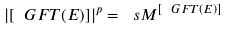Convert formula to latex. <formula><loc_0><loc_0><loc_500><loc_500>\left | [ \ G F T ( E ) ] \right | ^ { p } = \ s M ^ { [ \ G F T ( E ) ] }</formula> 